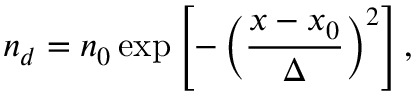<formula> <loc_0><loc_0><loc_500><loc_500>n _ { d } = n _ { 0 } \exp \left [ - \left ( \frac { x - x _ { 0 } } { \Delta } \right ) ^ { 2 } \right ] ,</formula> 